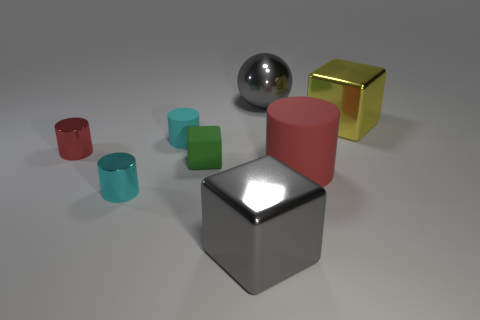What is the shape of the cyan shiny thing?
Your response must be concise. Cylinder. Do the small rubber cylinder and the rubber cylinder to the right of the green block have the same color?
Make the answer very short. No. Is the number of big yellow cubes to the left of the tiny cyan metal object greater than the number of tiny cyan rubber cylinders?
Give a very brief answer. No. How many things are objects in front of the cyan rubber thing or gray cubes on the left side of the big gray metal ball?
Provide a short and direct response. 5. What is the size of the cyan cylinder that is the same material as the tiny green cube?
Make the answer very short. Small. Is the shape of the tiny cyan object that is in front of the big red matte object the same as  the small red metallic object?
Make the answer very short. Yes. There is a metal block that is the same color as the metallic sphere; what size is it?
Provide a short and direct response. Large. What number of purple objects are either cubes or metallic cylinders?
Offer a very short reply. 0. How many other things are there of the same shape as the yellow metal object?
Make the answer very short. 2. There is a shiny object that is both in front of the green thing and to the right of the green thing; what is its shape?
Keep it short and to the point. Cube. 